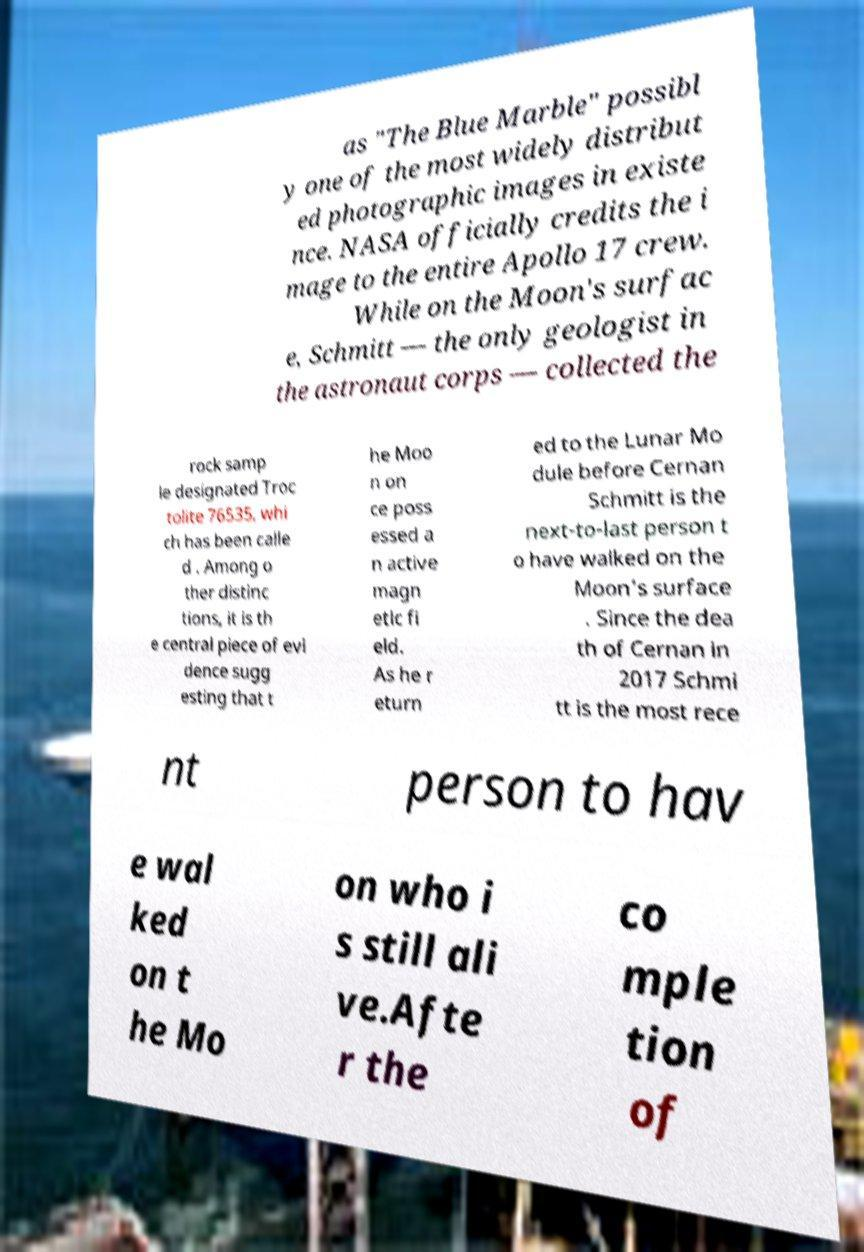I need the written content from this picture converted into text. Can you do that? as "The Blue Marble" possibl y one of the most widely distribut ed photographic images in existe nce. NASA officially credits the i mage to the entire Apollo 17 crew. While on the Moon's surfac e, Schmitt — the only geologist in the astronaut corps — collected the rock samp le designated Troc tolite 76535, whi ch has been calle d . Among o ther distinc tions, it is th e central piece of evi dence sugg esting that t he Moo n on ce poss essed a n active magn etic fi eld. As he r eturn ed to the Lunar Mo dule before Cernan Schmitt is the next-to-last person t o have walked on the Moon's surface . Since the dea th of Cernan in 2017 Schmi tt is the most rece nt person to hav e wal ked on t he Mo on who i s still ali ve.Afte r the co mple tion of 